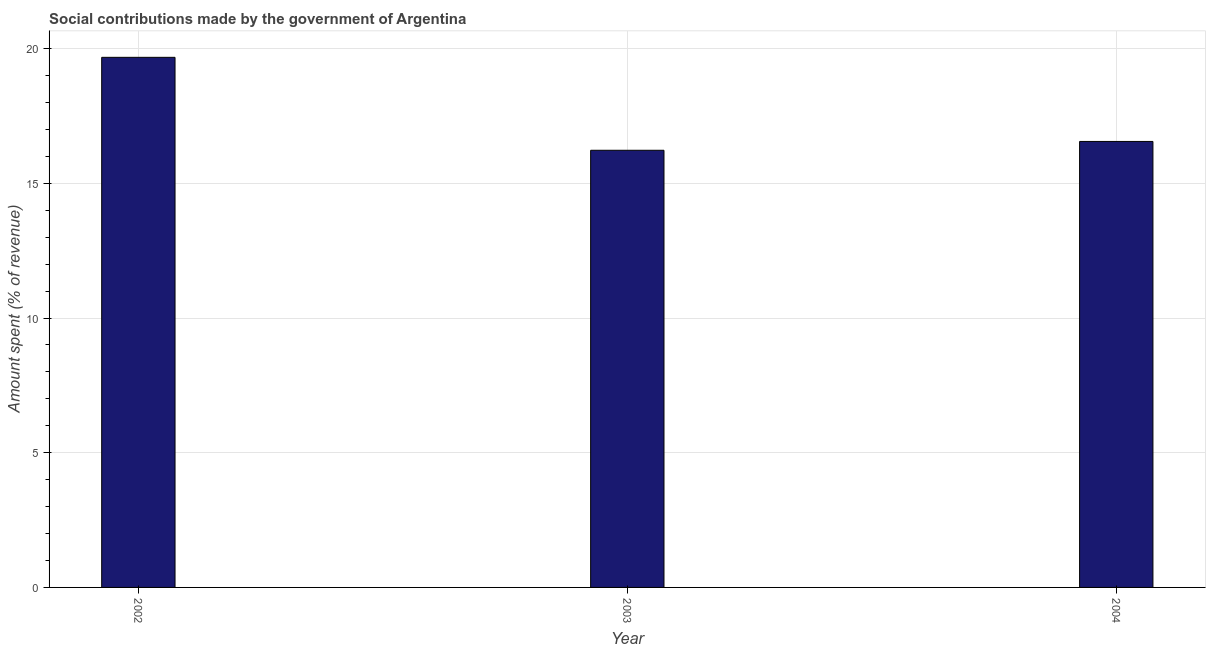Does the graph contain grids?
Your response must be concise. Yes. What is the title of the graph?
Your answer should be compact. Social contributions made by the government of Argentina. What is the label or title of the Y-axis?
Provide a short and direct response. Amount spent (% of revenue). What is the amount spent in making social contributions in 2002?
Provide a succinct answer. 19.68. Across all years, what is the maximum amount spent in making social contributions?
Offer a very short reply. 19.68. Across all years, what is the minimum amount spent in making social contributions?
Offer a very short reply. 16.23. In which year was the amount spent in making social contributions maximum?
Ensure brevity in your answer.  2002. In which year was the amount spent in making social contributions minimum?
Your answer should be compact. 2003. What is the sum of the amount spent in making social contributions?
Give a very brief answer. 52.46. What is the difference between the amount spent in making social contributions in 2002 and 2004?
Your answer should be compact. 3.12. What is the average amount spent in making social contributions per year?
Your response must be concise. 17.49. What is the median amount spent in making social contributions?
Provide a short and direct response. 16.56. Is the difference between the amount spent in making social contributions in 2003 and 2004 greater than the difference between any two years?
Your answer should be compact. No. What is the difference between the highest and the second highest amount spent in making social contributions?
Your answer should be very brief. 3.12. Is the sum of the amount spent in making social contributions in 2002 and 2004 greater than the maximum amount spent in making social contributions across all years?
Give a very brief answer. Yes. What is the difference between the highest and the lowest amount spent in making social contributions?
Provide a succinct answer. 3.45. In how many years, is the amount spent in making social contributions greater than the average amount spent in making social contributions taken over all years?
Your response must be concise. 1. What is the Amount spent (% of revenue) of 2002?
Provide a short and direct response. 19.68. What is the Amount spent (% of revenue) of 2003?
Your response must be concise. 16.23. What is the Amount spent (% of revenue) of 2004?
Offer a terse response. 16.56. What is the difference between the Amount spent (% of revenue) in 2002 and 2003?
Your response must be concise. 3.45. What is the difference between the Amount spent (% of revenue) in 2002 and 2004?
Your answer should be compact. 3.12. What is the difference between the Amount spent (% of revenue) in 2003 and 2004?
Provide a succinct answer. -0.33. What is the ratio of the Amount spent (% of revenue) in 2002 to that in 2003?
Keep it short and to the point. 1.21. What is the ratio of the Amount spent (% of revenue) in 2002 to that in 2004?
Keep it short and to the point. 1.19. What is the ratio of the Amount spent (% of revenue) in 2003 to that in 2004?
Offer a terse response. 0.98. 